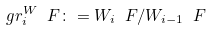Convert formula to latex. <formula><loc_0><loc_0><loc_500><loc_500>\ g r _ { i } ^ { W } \ F \colon = W _ { i } \ F / W _ { i - 1 } \ F</formula> 